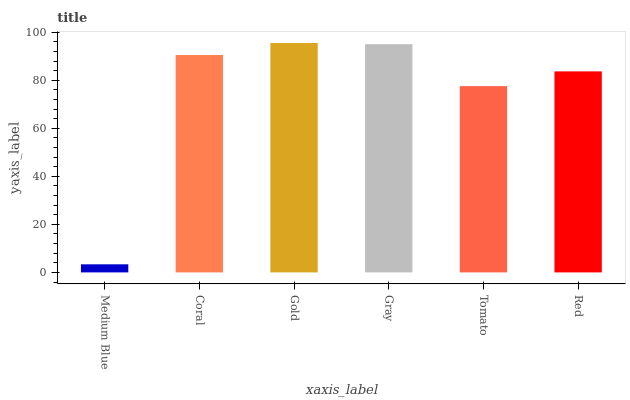Is Coral the minimum?
Answer yes or no. No. Is Coral the maximum?
Answer yes or no. No. Is Coral greater than Medium Blue?
Answer yes or no. Yes. Is Medium Blue less than Coral?
Answer yes or no. Yes. Is Medium Blue greater than Coral?
Answer yes or no. No. Is Coral less than Medium Blue?
Answer yes or no. No. Is Coral the high median?
Answer yes or no. Yes. Is Red the low median?
Answer yes or no. Yes. Is Red the high median?
Answer yes or no. No. Is Gold the low median?
Answer yes or no. No. 